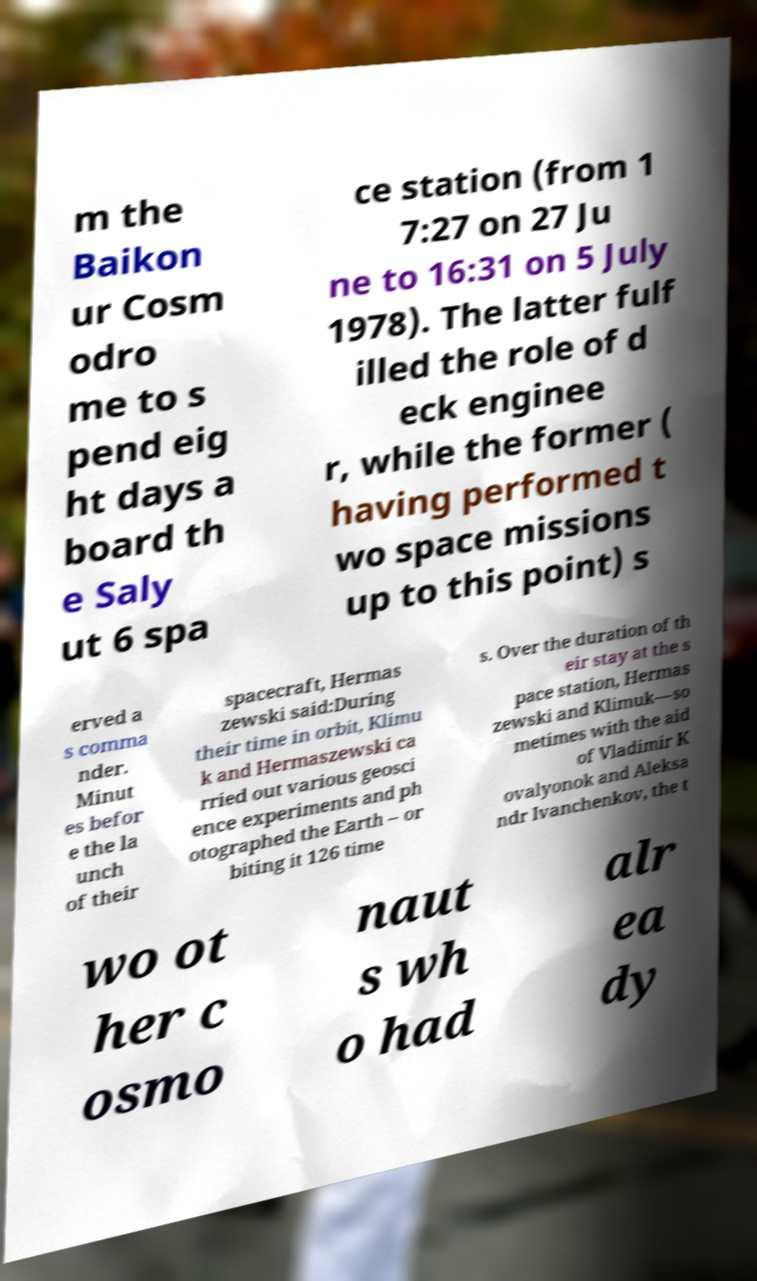Can you accurately transcribe the text from the provided image for me? m the Baikon ur Cosm odro me to s pend eig ht days a board th e Saly ut 6 spa ce station (from 1 7:27 on 27 Ju ne to 16:31 on 5 July 1978). The latter fulf illed the role of d eck enginee r, while the former ( having performed t wo space missions up to this point) s erved a s comma nder. Minut es befor e the la unch of their spacecraft, Hermas zewski said:During their time in orbit, Klimu k and Hermaszewski ca rried out various geosci ence experiments and ph otographed the Earth – or biting it 126 time s. Over the duration of th eir stay at the s pace station, Hermas zewski and Klimuk—so metimes with the aid of Vladimir K ovalyonok and Aleksa ndr Ivanchenkov, the t wo ot her c osmo naut s wh o had alr ea dy 